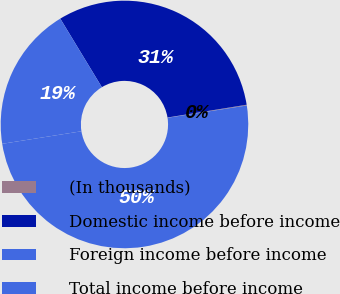<chart> <loc_0><loc_0><loc_500><loc_500><pie_chart><fcel>(In thousands)<fcel>Domestic income before income<fcel>Foreign income before income<fcel>Total income before income<nl><fcel>0.1%<fcel>31.13%<fcel>18.82%<fcel>49.95%<nl></chart> 